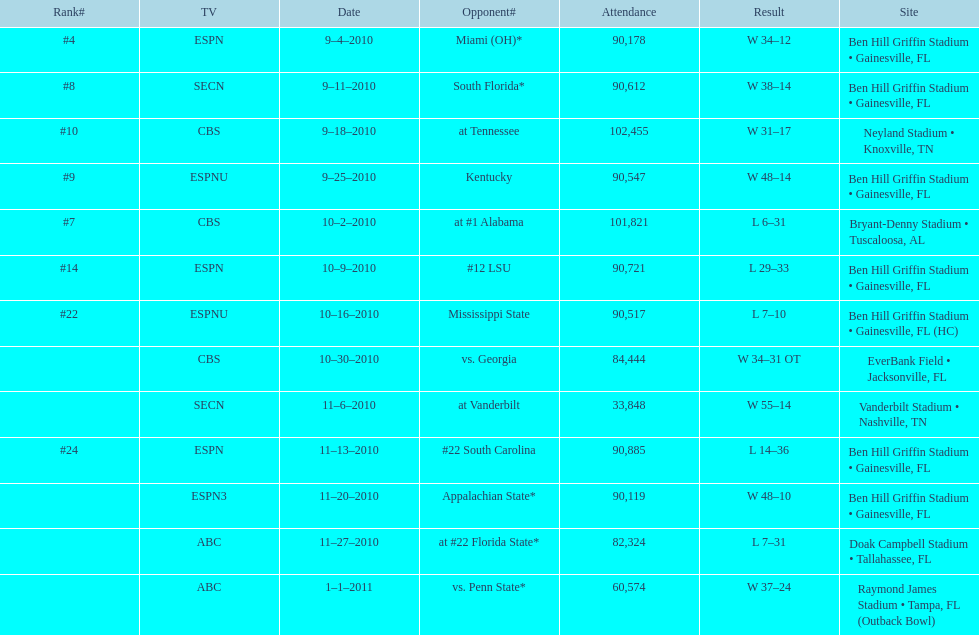How many games did the university of florida win by at least 10 points? 7. 